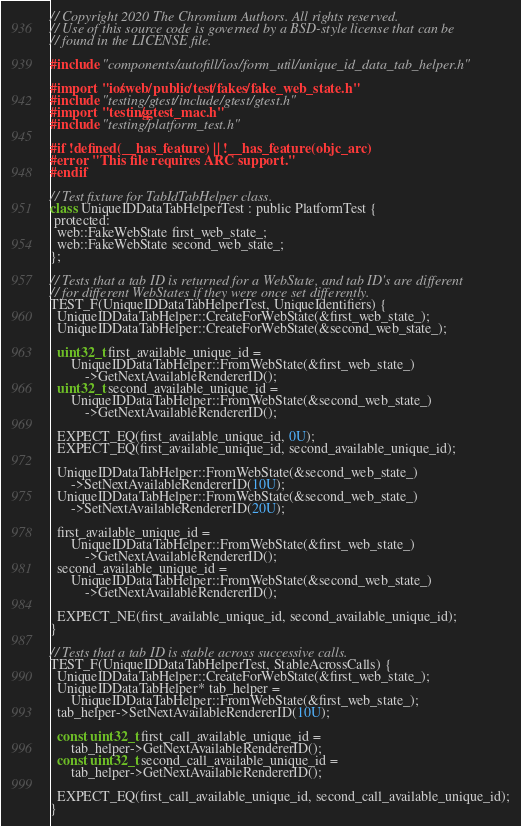Convert code to text. <code><loc_0><loc_0><loc_500><loc_500><_ObjectiveC_>// Copyright 2020 The Chromium Authors. All rights reserved.
// Use of this source code is governed by a BSD-style license that can be
// found in the LICENSE file.

#include "components/autofill/ios/form_util/unique_id_data_tab_helper.h"

#import "ios/web/public/test/fakes/fake_web_state.h"
#include "testing/gtest/include/gtest/gtest.h"
#import "testing/gtest_mac.h"
#include "testing/platform_test.h"

#if !defined(__has_feature) || !__has_feature(objc_arc)
#error "This file requires ARC support."
#endif

// Test fixture for TabIdTabHelper class.
class UniqueIDDataTabHelperTest : public PlatformTest {
 protected:
  web::FakeWebState first_web_state_;
  web::FakeWebState second_web_state_;
};

// Tests that a tab ID is returned for a WebState, and tab ID's are different
// for different WebStates if they were once set differently.
TEST_F(UniqueIDDataTabHelperTest, UniqueIdentifiers) {
  UniqueIDDataTabHelper::CreateForWebState(&first_web_state_);
  UniqueIDDataTabHelper::CreateForWebState(&second_web_state_);

  uint32_t first_available_unique_id =
      UniqueIDDataTabHelper::FromWebState(&first_web_state_)
          ->GetNextAvailableRendererID();
  uint32_t second_available_unique_id =
      UniqueIDDataTabHelper::FromWebState(&second_web_state_)
          ->GetNextAvailableRendererID();

  EXPECT_EQ(first_available_unique_id, 0U);
  EXPECT_EQ(first_available_unique_id, second_available_unique_id);

  UniqueIDDataTabHelper::FromWebState(&second_web_state_)
      ->SetNextAvailableRendererID(10U);
  UniqueIDDataTabHelper::FromWebState(&second_web_state_)
      ->SetNextAvailableRendererID(20U);

  first_available_unique_id =
      UniqueIDDataTabHelper::FromWebState(&first_web_state_)
          ->GetNextAvailableRendererID();
  second_available_unique_id =
      UniqueIDDataTabHelper::FromWebState(&second_web_state_)
          ->GetNextAvailableRendererID();

  EXPECT_NE(first_available_unique_id, second_available_unique_id);
}

// Tests that a tab ID is stable across successive calls.
TEST_F(UniqueIDDataTabHelperTest, StableAcrossCalls) {
  UniqueIDDataTabHelper::CreateForWebState(&first_web_state_);
  UniqueIDDataTabHelper* tab_helper =
      UniqueIDDataTabHelper::FromWebState(&first_web_state_);
  tab_helper->SetNextAvailableRendererID(10U);

  const uint32_t first_call_available_unique_id =
      tab_helper->GetNextAvailableRendererID();
  const uint32_t second_call_available_unique_id =
      tab_helper->GetNextAvailableRendererID();

  EXPECT_EQ(first_call_available_unique_id, second_call_available_unique_id);
}
</code> 